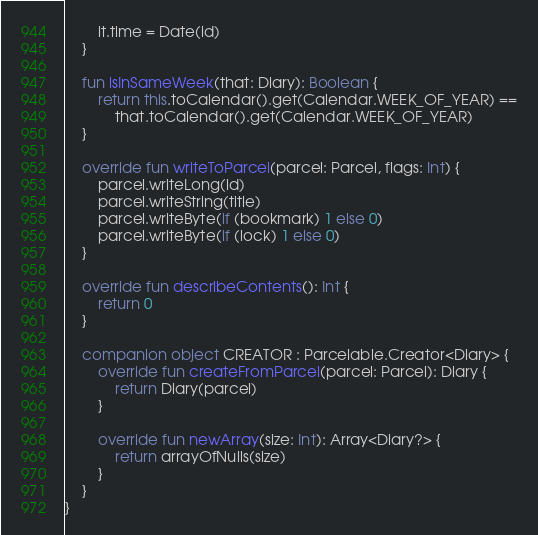Convert code to text. <code><loc_0><loc_0><loc_500><loc_500><_Kotlin_>        it.time = Date(id)
    }

    fun isInSameWeek(that: Diary): Boolean {
        return this.toCalendar().get(Calendar.WEEK_OF_YEAR) ==
            that.toCalendar().get(Calendar.WEEK_OF_YEAR)
    }

    override fun writeToParcel(parcel: Parcel, flags: Int) {
        parcel.writeLong(id)
        parcel.writeString(title)
        parcel.writeByte(if (bookmark) 1 else 0)
        parcel.writeByte(if (lock) 1 else 0)
    }

    override fun describeContents(): Int {
        return 0
    }

    companion object CREATOR : Parcelable.Creator<Diary> {
        override fun createFromParcel(parcel: Parcel): Diary {
            return Diary(parcel)
        }

        override fun newArray(size: Int): Array<Diary?> {
            return arrayOfNulls(size)
        }
    }
}
</code> 